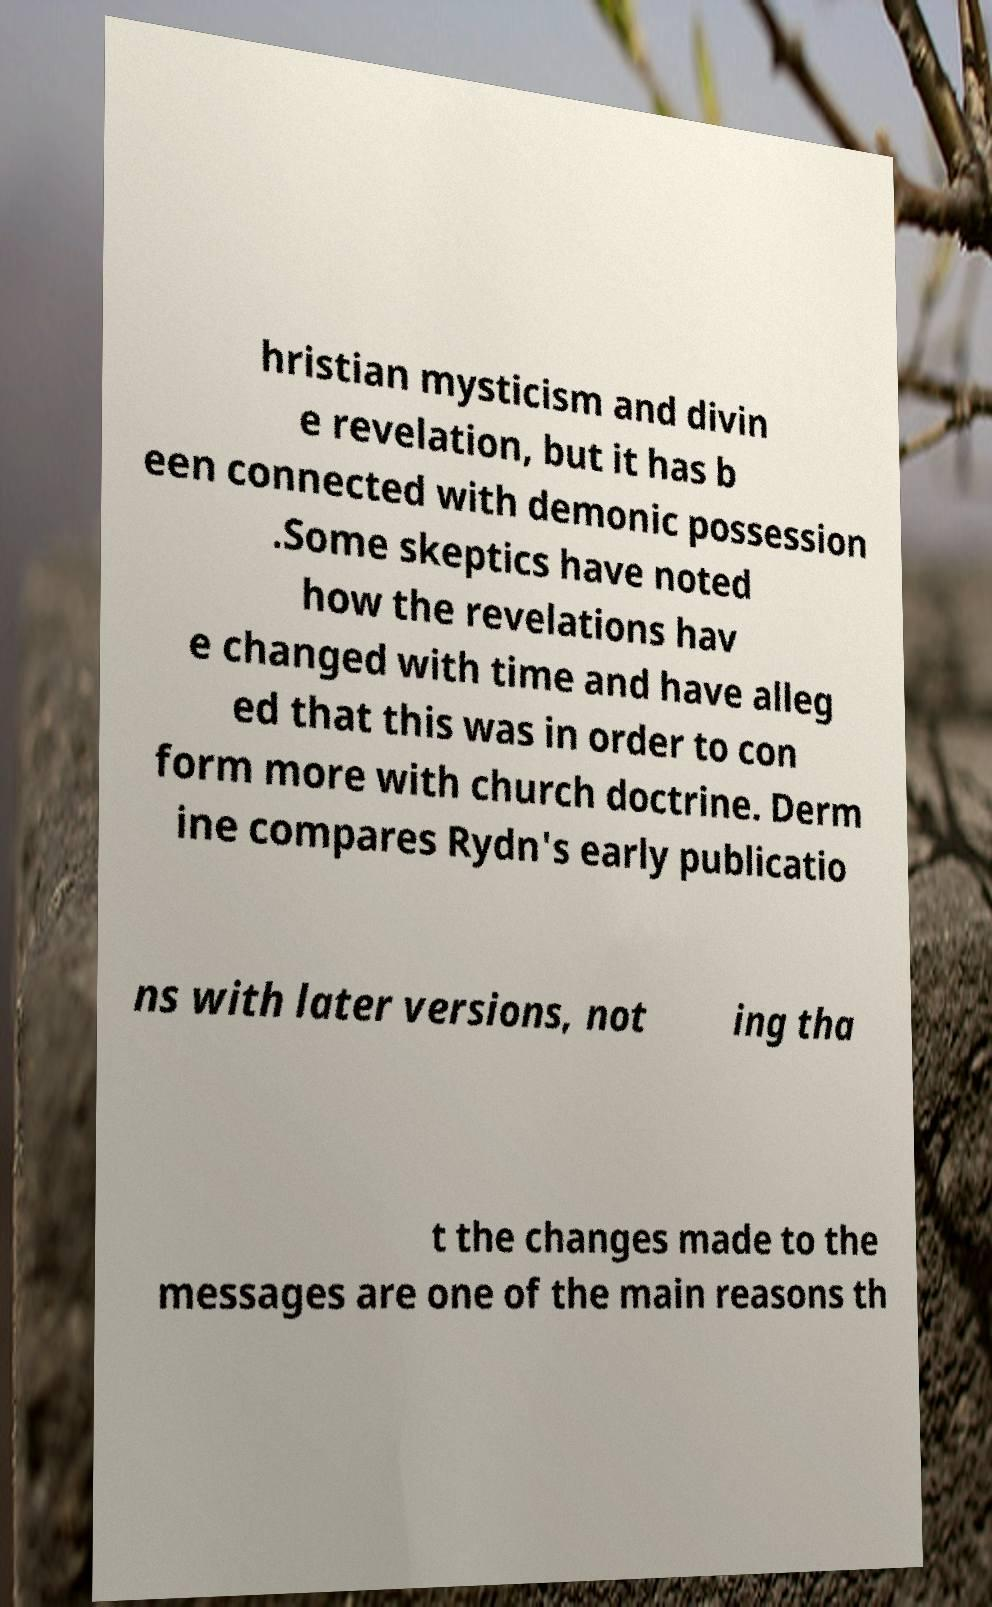For documentation purposes, I need the text within this image transcribed. Could you provide that? hristian mysticism and divin e revelation, but it has b een connected with demonic possession .Some skeptics have noted how the revelations hav e changed with time and have alleg ed that this was in order to con form more with church doctrine. Derm ine compares Rydn's early publicatio ns with later versions, not ing tha t the changes made to the messages are one of the main reasons th 